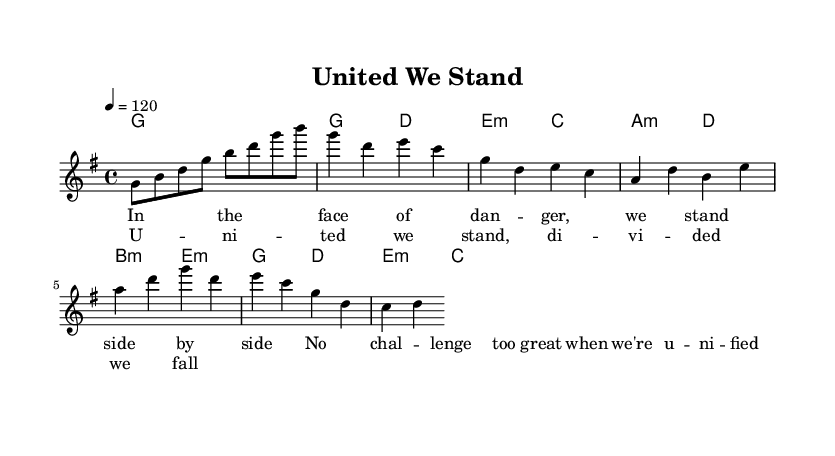What is the key signature of this music? The key signature is G major, indicated by one sharp (F#) in the score. This can be identified in the global section near the top.
Answer: G major What is the time signature of this music? The time signature is 4/4, shown in the global section of the score. This indicates there are four beats per measure.
Answer: 4/4 What is the tempo marking of this music? The tempo marking is 120 beats per minute, specified in the global section. This dictates the pace of the song.
Answer: 120 How many measures are in the chorus? The chorus consists of two measures, as indicated by the analysis of the chorus section in the sheet music. Each section is counted according to the measures notated.
Answer: 2 What is the lyrical theme of the verse? The lyrics of the verse emphasize standing together and facing danger as a united front, reflecting a theme of collaboration. This can be discerned by reading through the lyrics present in the verse section.
Answer: Unity How many chords are played in the pre-chorus? There are four chords played in the pre-chorus section, listed in the harmonies line for that part of the song. Each chord corresponds to a measure, indicating structured harmonic support.
Answer: 4 What does the term "unified" in the lyrics suggest in the context of K-Pop? The term "unified" suggests a strong message of teamwork and collaboration, which is common in K-Pop themes, emphasizing collective strength and support during challenges. This interpretation aligns with the overall theme of resilience present in K-Pop music.
Answer: Teamwork 